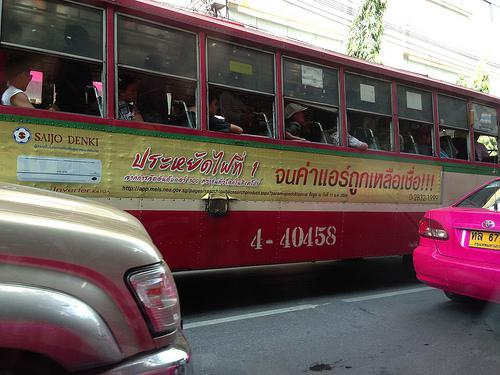Question: how many vehicles are in the photo?
Choices:
A. Five.
B. Two.
C. Three.
D. .One.
Answer with the letter. Answer: C Question: how many pink cars are in the picture?
Choices:
A. Two.
B. Four.
C. One.
D. Six.
Answer with the letter. Answer: C Question: how many buses are in the photo?
Choices:
A. One.
B. Three.
C. None.
D. Two.
Answer with the letter. Answer: A Question: where is this taking place?
Choices:
A. On the street.
B. At school.
C. A game.
D. A concert.
Answer with the letter. Answer: A 